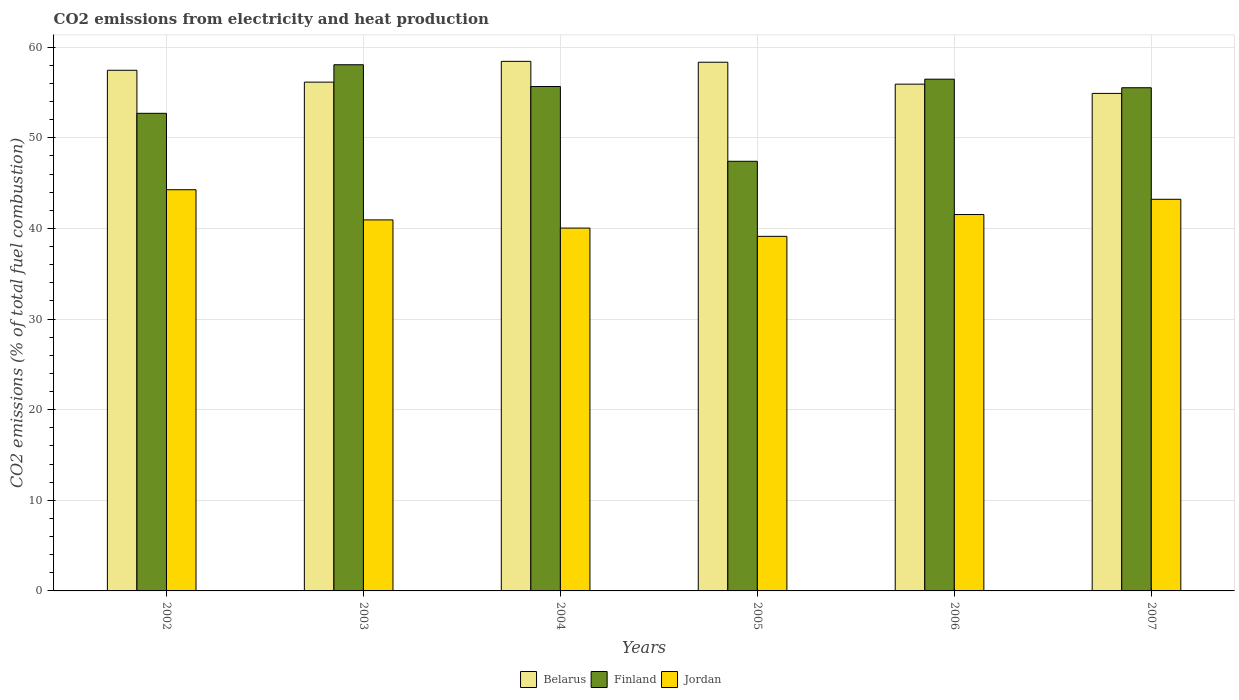How many bars are there on the 4th tick from the right?
Give a very brief answer. 3. What is the label of the 1st group of bars from the left?
Your answer should be compact. 2002. What is the amount of CO2 emitted in Belarus in 2006?
Your answer should be very brief. 55.92. Across all years, what is the maximum amount of CO2 emitted in Belarus?
Offer a very short reply. 58.43. Across all years, what is the minimum amount of CO2 emitted in Jordan?
Ensure brevity in your answer.  39.12. In which year was the amount of CO2 emitted in Belarus minimum?
Provide a succinct answer. 2007. What is the total amount of CO2 emitted in Belarus in the graph?
Keep it short and to the point. 341.17. What is the difference between the amount of CO2 emitted in Belarus in 2003 and that in 2005?
Offer a very short reply. -2.2. What is the difference between the amount of CO2 emitted in Belarus in 2005 and the amount of CO2 emitted in Finland in 2002?
Ensure brevity in your answer.  5.64. What is the average amount of CO2 emitted in Belarus per year?
Make the answer very short. 56.86. In the year 2007, what is the difference between the amount of CO2 emitted in Jordan and amount of CO2 emitted in Finland?
Ensure brevity in your answer.  -12.31. In how many years, is the amount of CO2 emitted in Finland greater than 38 %?
Your response must be concise. 6. What is the ratio of the amount of CO2 emitted in Jordan in 2003 to that in 2006?
Ensure brevity in your answer.  0.99. Is the difference between the amount of CO2 emitted in Jordan in 2002 and 2004 greater than the difference between the amount of CO2 emitted in Finland in 2002 and 2004?
Your response must be concise. Yes. What is the difference between the highest and the second highest amount of CO2 emitted in Jordan?
Keep it short and to the point. 1.05. What is the difference between the highest and the lowest amount of CO2 emitted in Jordan?
Keep it short and to the point. 5.14. In how many years, is the amount of CO2 emitted in Finland greater than the average amount of CO2 emitted in Finland taken over all years?
Offer a terse response. 4. Is the sum of the amount of CO2 emitted in Finland in 2003 and 2007 greater than the maximum amount of CO2 emitted in Jordan across all years?
Provide a short and direct response. Yes. What does the 3rd bar from the left in 2006 represents?
Provide a succinct answer. Jordan. What does the 3rd bar from the right in 2007 represents?
Make the answer very short. Belarus. Is it the case that in every year, the sum of the amount of CO2 emitted in Jordan and amount of CO2 emitted in Finland is greater than the amount of CO2 emitted in Belarus?
Provide a short and direct response. Yes. Are all the bars in the graph horizontal?
Ensure brevity in your answer.  No. How many years are there in the graph?
Your answer should be very brief. 6. What is the difference between two consecutive major ticks on the Y-axis?
Provide a succinct answer. 10. What is the title of the graph?
Your answer should be very brief. CO2 emissions from electricity and heat production. Does "Fragile and conflict affected situations" appear as one of the legend labels in the graph?
Provide a succinct answer. No. What is the label or title of the X-axis?
Provide a short and direct response. Years. What is the label or title of the Y-axis?
Your answer should be compact. CO2 emissions (% of total fuel combustion). What is the CO2 emissions (% of total fuel combustion) in Belarus in 2002?
Keep it short and to the point. 57.45. What is the CO2 emissions (% of total fuel combustion) in Finland in 2002?
Your answer should be compact. 52.7. What is the CO2 emissions (% of total fuel combustion) in Jordan in 2002?
Ensure brevity in your answer.  44.27. What is the CO2 emissions (% of total fuel combustion) of Belarus in 2003?
Your answer should be compact. 56.14. What is the CO2 emissions (% of total fuel combustion) in Finland in 2003?
Offer a terse response. 58.06. What is the CO2 emissions (% of total fuel combustion) of Jordan in 2003?
Ensure brevity in your answer.  40.94. What is the CO2 emissions (% of total fuel combustion) in Belarus in 2004?
Your response must be concise. 58.43. What is the CO2 emissions (% of total fuel combustion) in Finland in 2004?
Provide a succinct answer. 55.66. What is the CO2 emissions (% of total fuel combustion) of Jordan in 2004?
Offer a terse response. 40.04. What is the CO2 emissions (% of total fuel combustion) in Belarus in 2005?
Your answer should be compact. 58.34. What is the CO2 emissions (% of total fuel combustion) of Finland in 2005?
Ensure brevity in your answer.  47.41. What is the CO2 emissions (% of total fuel combustion) in Jordan in 2005?
Your response must be concise. 39.12. What is the CO2 emissions (% of total fuel combustion) in Belarus in 2006?
Provide a succinct answer. 55.92. What is the CO2 emissions (% of total fuel combustion) in Finland in 2006?
Keep it short and to the point. 56.47. What is the CO2 emissions (% of total fuel combustion) in Jordan in 2006?
Your answer should be compact. 41.53. What is the CO2 emissions (% of total fuel combustion) in Belarus in 2007?
Your answer should be compact. 54.9. What is the CO2 emissions (% of total fuel combustion) in Finland in 2007?
Provide a succinct answer. 55.52. What is the CO2 emissions (% of total fuel combustion) of Jordan in 2007?
Your answer should be very brief. 43.21. Across all years, what is the maximum CO2 emissions (% of total fuel combustion) of Belarus?
Provide a short and direct response. 58.43. Across all years, what is the maximum CO2 emissions (% of total fuel combustion) in Finland?
Your answer should be compact. 58.06. Across all years, what is the maximum CO2 emissions (% of total fuel combustion) in Jordan?
Make the answer very short. 44.27. Across all years, what is the minimum CO2 emissions (% of total fuel combustion) of Belarus?
Your answer should be very brief. 54.9. Across all years, what is the minimum CO2 emissions (% of total fuel combustion) of Finland?
Offer a very short reply. 47.41. Across all years, what is the minimum CO2 emissions (% of total fuel combustion) of Jordan?
Ensure brevity in your answer.  39.12. What is the total CO2 emissions (% of total fuel combustion) of Belarus in the graph?
Provide a succinct answer. 341.17. What is the total CO2 emissions (% of total fuel combustion) in Finland in the graph?
Give a very brief answer. 325.81. What is the total CO2 emissions (% of total fuel combustion) in Jordan in the graph?
Your answer should be very brief. 249.11. What is the difference between the CO2 emissions (% of total fuel combustion) of Belarus in 2002 and that in 2003?
Keep it short and to the point. 1.31. What is the difference between the CO2 emissions (% of total fuel combustion) in Finland in 2002 and that in 2003?
Keep it short and to the point. -5.36. What is the difference between the CO2 emissions (% of total fuel combustion) of Jordan in 2002 and that in 2003?
Give a very brief answer. 3.33. What is the difference between the CO2 emissions (% of total fuel combustion) of Belarus in 2002 and that in 2004?
Give a very brief answer. -0.98. What is the difference between the CO2 emissions (% of total fuel combustion) in Finland in 2002 and that in 2004?
Provide a short and direct response. -2.96. What is the difference between the CO2 emissions (% of total fuel combustion) in Jordan in 2002 and that in 2004?
Keep it short and to the point. 4.23. What is the difference between the CO2 emissions (% of total fuel combustion) in Belarus in 2002 and that in 2005?
Offer a very short reply. -0.89. What is the difference between the CO2 emissions (% of total fuel combustion) in Finland in 2002 and that in 2005?
Provide a short and direct response. 5.29. What is the difference between the CO2 emissions (% of total fuel combustion) of Jordan in 2002 and that in 2005?
Offer a very short reply. 5.14. What is the difference between the CO2 emissions (% of total fuel combustion) in Belarus in 2002 and that in 2006?
Offer a very short reply. 1.53. What is the difference between the CO2 emissions (% of total fuel combustion) of Finland in 2002 and that in 2006?
Your answer should be compact. -3.77. What is the difference between the CO2 emissions (% of total fuel combustion) of Jordan in 2002 and that in 2006?
Make the answer very short. 2.74. What is the difference between the CO2 emissions (% of total fuel combustion) of Belarus in 2002 and that in 2007?
Your answer should be very brief. 2.55. What is the difference between the CO2 emissions (% of total fuel combustion) in Finland in 2002 and that in 2007?
Your answer should be compact. -2.82. What is the difference between the CO2 emissions (% of total fuel combustion) in Jordan in 2002 and that in 2007?
Keep it short and to the point. 1.05. What is the difference between the CO2 emissions (% of total fuel combustion) in Belarus in 2003 and that in 2004?
Make the answer very short. -2.29. What is the difference between the CO2 emissions (% of total fuel combustion) in Finland in 2003 and that in 2004?
Offer a terse response. 2.4. What is the difference between the CO2 emissions (% of total fuel combustion) of Jordan in 2003 and that in 2004?
Give a very brief answer. 0.9. What is the difference between the CO2 emissions (% of total fuel combustion) in Belarus in 2003 and that in 2005?
Keep it short and to the point. -2.2. What is the difference between the CO2 emissions (% of total fuel combustion) in Finland in 2003 and that in 2005?
Your answer should be compact. 10.65. What is the difference between the CO2 emissions (% of total fuel combustion) of Jordan in 2003 and that in 2005?
Provide a succinct answer. 1.82. What is the difference between the CO2 emissions (% of total fuel combustion) in Belarus in 2003 and that in 2006?
Provide a succinct answer. 0.22. What is the difference between the CO2 emissions (% of total fuel combustion) of Finland in 2003 and that in 2006?
Your response must be concise. 1.59. What is the difference between the CO2 emissions (% of total fuel combustion) of Jordan in 2003 and that in 2006?
Your answer should be very brief. -0.59. What is the difference between the CO2 emissions (% of total fuel combustion) in Belarus in 2003 and that in 2007?
Keep it short and to the point. 1.24. What is the difference between the CO2 emissions (% of total fuel combustion) in Finland in 2003 and that in 2007?
Your response must be concise. 2.54. What is the difference between the CO2 emissions (% of total fuel combustion) of Jordan in 2003 and that in 2007?
Offer a terse response. -2.27. What is the difference between the CO2 emissions (% of total fuel combustion) in Belarus in 2004 and that in 2005?
Make the answer very short. 0.1. What is the difference between the CO2 emissions (% of total fuel combustion) in Finland in 2004 and that in 2005?
Your response must be concise. 8.25. What is the difference between the CO2 emissions (% of total fuel combustion) in Jordan in 2004 and that in 2005?
Give a very brief answer. 0.91. What is the difference between the CO2 emissions (% of total fuel combustion) of Belarus in 2004 and that in 2006?
Make the answer very short. 2.52. What is the difference between the CO2 emissions (% of total fuel combustion) of Finland in 2004 and that in 2006?
Provide a succinct answer. -0.81. What is the difference between the CO2 emissions (% of total fuel combustion) in Jordan in 2004 and that in 2006?
Your response must be concise. -1.5. What is the difference between the CO2 emissions (% of total fuel combustion) of Belarus in 2004 and that in 2007?
Offer a very short reply. 3.54. What is the difference between the CO2 emissions (% of total fuel combustion) in Finland in 2004 and that in 2007?
Your answer should be compact. 0.14. What is the difference between the CO2 emissions (% of total fuel combustion) of Jordan in 2004 and that in 2007?
Give a very brief answer. -3.18. What is the difference between the CO2 emissions (% of total fuel combustion) of Belarus in 2005 and that in 2006?
Your answer should be very brief. 2.42. What is the difference between the CO2 emissions (% of total fuel combustion) of Finland in 2005 and that in 2006?
Make the answer very short. -9.06. What is the difference between the CO2 emissions (% of total fuel combustion) in Jordan in 2005 and that in 2006?
Give a very brief answer. -2.41. What is the difference between the CO2 emissions (% of total fuel combustion) in Belarus in 2005 and that in 2007?
Your answer should be very brief. 3.44. What is the difference between the CO2 emissions (% of total fuel combustion) in Finland in 2005 and that in 2007?
Provide a succinct answer. -8.12. What is the difference between the CO2 emissions (% of total fuel combustion) of Jordan in 2005 and that in 2007?
Offer a very short reply. -4.09. What is the difference between the CO2 emissions (% of total fuel combustion) of Belarus in 2006 and that in 2007?
Your answer should be very brief. 1.02. What is the difference between the CO2 emissions (% of total fuel combustion) of Finland in 2006 and that in 2007?
Provide a short and direct response. 0.95. What is the difference between the CO2 emissions (% of total fuel combustion) of Jordan in 2006 and that in 2007?
Make the answer very short. -1.68. What is the difference between the CO2 emissions (% of total fuel combustion) in Belarus in 2002 and the CO2 emissions (% of total fuel combustion) in Finland in 2003?
Keep it short and to the point. -0.61. What is the difference between the CO2 emissions (% of total fuel combustion) of Belarus in 2002 and the CO2 emissions (% of total fuel combustion) of Jordan in 2003?
Your response must be concise. 16.51. What is the difference between the CO2 emissions (% of total fuel combustion) in Finland in 2002 and the CO2 emissions (% of total fuel combustion) in Jordan in 2003?
Make the answer very short. 11.76. What is the difference between the CO2 emissions (% of total fuel combustion) of Belarus in 2002 and the CO2 emissions (% of total fuel combustion) of Finland in 2004?
Offer a very short reply. 1.79. What is the difference between the CO2 emissions (% of total fuel combustion) of Belarus in 2002 and the CO2 emissions (% of total fuel combustion) of Jordan in 2004?
Ensure brevity in your answer.  17.41. What is the difference between the CO2 emissions (% of total fuel combustion) of Finland in 2002 and the CO2 emissions (% of total fuel combustion) of Jordan in 2004?
Offer a terse response. 12.66. What is the difference between the CO2 emissions (% of total fuel combustion) in Belarus in 2002 and the CO2 emissions (% of total fuel combustion) in Finland in 2005?
Offer a terse response. 10.04. What is the difference between the CO2 emissions (% of total fuel combustion) in Belarus in 2002 and the CO2 emissions (% of total fuel combustion) in Jordan in 2005?
Your response must be concise. 18.32. What is the difference between the CO2 emissions (% of total fuel combustion) of Finland in 2002 and the CO2 emissions (% of total fuel combustion) of Jordan in 2005?
Your answer should be compact. 13.58. What is the difference between the CO2 emissions (% of total fuel combustion) in Belarus in 2002 and the CO2 emissions (% of total fuel combustion) in Finland in 2006?
Offer a terse response. 0.98. What is the difference between the CO2 emissions (% of total fuel combustion) of Belarus in 2002 and the CO2 emissions (% of total fuel combustion) of Jordan in 2006?
Your answer should be compact. 15.92. What is the difference between the CO2 emissions (% of total fuel combustion) in Finland in 2002 and the CO2 emissions (% of total fuel combustion) in Jordan in 2006?
Offer a very short reply. 11.17. What is the difference between the CO2 emissions (% of total fuel combustion) in Belarus in 2002 and the CO2 emissions (% of total fuel combustion) in Finland in 2007?
Provide a succinct answer. 1.93. What is the difference between the CO2 emissions (% of total fuel combustion) in Belarus in 2002 and the CO2 emissions (% of total fuel combustion) in Jordan in 2007?
Offer a terse response. 14.23. What is the difference between the CO2 emissions (% of total fuel combustion) of Finland in 2002 and the CO2 emissions (% of total fuel combustion) of Jordan in 2007?
Keep it short and to the point. 9.48. What is the difference between the CO2 emissions (% of total fuel combustion) in Belarus in 2003 and the CO2 emissions (% of total fuel combustion) in Finland in 2004?
Your response must be concise. 0.48. What is the difference between the CO2 emissions (% of total fuel combustion) of Belarus in 2003 and the CO2 emissions (% of total fuel combustion) of Jordan in 2004?
Your answer should be very brief. 16.1. What is the difference between the CO2 emissions (% of total fuel combustion) of Finland in 2003 and the CO2 emissions (% of total fuel combustion) of Jordan in 2004?
Keep it short and to the point. 18.02. What is the difference between the CO2 emissions (% of total fuel combustion) of Belarus in 2003 and the CO2 emissions (% of total fuel combustion) of Finland in 2005?
Offer a terse response. 8.73. What is the difference between the CO2 emissions (% of total fuel combustion) in Belarus in 2003 and the CO2 emissions (% of total fuel combustion) in Jordan in 2005?
Make the answer very short. 17.02. What is the difference between the CO2 emissions (% of total fuel combustion) in Finland in 2003 and the CO2 emissions (% of total fuel combustion) in Jordan in 2005?
Your answer should be compact. 18.94. What is the difference between the CO2 emissions (% of total fuel combustion) of Belarus in 2003 and the CO2 emissions (% of total fuel combustion) of Finland in 2006?
Ensure brevity in your answer.  -0.33. What is the difference between the CO2 emissions (% of total fuel combustion) of Belarus in 2003 and the CO2 emissions (% of total fuel combustion) of Jordan in 2006?
Offer a terse response. 14.61. What is the difference between the CO2 emissions (% of total fuel combustion) of Finland in 2003 and the CO2 emissions (% of total fuel combustion) of Jordan in 2006?
Provide a succinct answer. 16.53. What is the difference between the CO2 emissions (% of total fuel combustion) of Belarus in 2003 and the CO2 emissions (% of total fuel combustion) of Finland in 2007?
Your answer should be very brief. 0.62. What is the difference between the CO2 emissions (% of total fuel combustion) in Belarus in 2003 and the CO2 emissions (% of total fuel combustion) in Jordan in 2007?
Provide a short and direct response. 12.93. What is the difference between the CO2 emissions (% of total fuel combustion) in Finland in 2003 and the CO2 emissions (% of total fuel combustion) in Jordan in 2007?
Your response must be concise. 14.85. What is the difference between the CO2 emissions (% of total fuel combustion) of Belarus in 2004 and the CO2 emissions (% of total fuel combustion) of Finland in 2005?
Your answer should be very brief. 11.03. What is the difference between the CO2 emissions (% of total fuel combustion) of Belarus in 2004 and the CO2 emissions (% of total fuel combustion) of Jordan in 2005?
Provide a short and direct response. 19.31. What is the difference between the CO2 emissions (% of total fuel combustion) of Finland in 2004 and the CO2 emissions (% of total fuel combustion) of Jordan in 2005?
Offer a terse response. 16.53. What is the difference between the CO2 emissions (% of total fuel combustion) of Belarus in 2004 and the CO2 emissions (% of total fuel combustion) of Finland in 2006?
Ensure brevity in your answer.  1.97. What is the difference between the CO2 emissions (% of total fuel combustion) in Belarus in 2004 and the CO2 emissions (% of total fuel combustion) in Jordan in 2006?
Your answer should be compact. 16.9. What is the difference between the CO2 emissions (% of total fuel combustion) of Finland in 2004 and the CO2 emissions (% of total fuel combustion) of Jordan in 2006?
Provide a short and direct response. 14.13. What is the difference between the CO2 emissions (% of total fuel combustion) of Belarus in 2004 and the CO2 emissions (% of total fuel combustion) of Finland in 2007?
Your response must be concise. 2.91. What is the difference between the CO2 emissions (% of total fuel combustion) of Belarus in 2004 and the CO2 emissions (% of total fuel combustion) of Jordan in 2007?
Give a very brief answer. 15.22. What is the difference between the CO2 emissions (% of total fuel combustion) of Finland in 2004 and the CO2 emissions (% of total fuel combustion) of Jordan in 2007?
Give a very brief answer. 12.44. What is the difference between the CO2 emissions (% of total fuel combustion) in Belarus in 2005 and the CO2 emissions (% of total fuel combustion) in Finland in 2006?
Provide a short and direct response. 1.87. What is the difference between the CO2 emissions (% of total fuel combustion) of Belarus in 2005 and the CO2 emissions (% of total fuel combustion) of Jordan in 2006?
Offer a terse response. 16.81. What is the difference between the CO2 emissions (% of total fuel combustion) in Finland in 2005 and the CO2 emissions (% of total fuel combustion) in Jordan in 2006?
Make the answer very short. 5.87. What is the difference between the CO2 emissions (% of total fuel combustion) of Belarus in 2005 and the CO2 emissions (% of total fuel combustion) of Finland in 2007?
Ensure brevity in your answer.  2.82. What is the difference between the CO2 emissions (% of total fuel combustion) in Belarus in 2005 and the CO2 emissions (% of total fuel combustion) in Jordan in 2007?
Offer a very short reply. 15.12. What is the difference between the CO2 emissions (% of total fuel combustion) in Finland in 2005 and the CO2 emissions (% of total fuel combustion) in Jordan in 2007?
Offer a terse response. 4.19. What is the difference between the CO2 emissions (% of total fuel combustion) of Belarus in 2006 and the CO2 emissions (% of total fuel combustion) of Finland in 2007?
Your answer should be very brief. 0.4. What is the difference between the CO2 emissions (% of total fuel combustion) of Belarus in 2006 and the CO2 emissions (% of total fuel combustion) of Jordan in 2007?
Offer a terse response. 12.7. What is the difference between the CO2 emissions (% of total fuel combustion) in Finland in 2006 and the CO2 emissions (% of total fuel combustion) in Jordan in 2007?
Your response must be concise. 13.25. What is the average CO2 emissions (% of total fuel combustion) of Belarus per year?
Keep it short and to the point. 56.86. What is the average CO2 emissions (% of total fuel combustion) in Finland per year?
Offer a terse response. 54.3. What is the average CO2 emissions (% of total fuel combustion) of Jordan per year?
Your response must be concise. 41.52. In the year 2002, what is the difference between the CO2 emissions (% of total fuel combustion) of Belarus and CO2 emissions (% of total fuel combustion) of Finland?
Offer a very short reply. 4.75. In the year 2002, what is the difference between the CO2 emissions (% of total fuel combustion) of Belarus and CO2 emissions (% of total fuel combustion) of Jordan?
Provide a succinct answer. 13.18. In the year 2002, what is the difference between the CO2 emissions (% of total fuel combustion) in Finland and CO2 emissions (% of total fuel combustion) in Jordan?
Your answer should be compact. 8.43. In the year 2003, what is the difference between the CO2 emissions (% of total fuel combustion) in Belarus and CO2 emissions (% of total fuel combustion) in Finland?
Give a very brief answer. -1.92. In the year 2003, what is the difference between the CO2 emissions (% of total fuel combustion) in Belarus and CO2 emissions (% of total fuel combustion) in Jordan?
Your answer should be compact. 15.2. In the year 2003, what is the difference between the CO2 emissions (% of total fuel combustion) in Finland and CO2 emissions (% of total fuel combustion) in Jordan?
Provide a short and direct response. 17.12. In the year 2004, what is the difference between the CO2 emissions (% of total fuel combustion) of Belarus and CO2 emissions (% of total fuel combustion) of Finland?
Your answer should be very brief. 2.78. In the year 2004, what is the difference between the CO2 emissions (% of total fuel combustion) in Belarus and CO2 emissions (% of total fuel combustion) in Jordan?
Give a very brief answer. 18.4. In the year 2004, what is the difference between the CO2 emissions (% of total fuel combustion) in Finland and CO2 emissions (% of total fuel combustion) in Jordan?
Your answer should be very brief. 15.62. In the year 2005, what is the difference between the CO2 emissions (% of total fuel combustion) of Belarus and CO2 emissions (% of total fuel combustion) of Finland?
Keep it short and to the point. 10.93. In the year 2005, what is the difference between the CO2 emissions (% of total fuel combustion) of Belarus and CO2 emissions (% of total fuel combustion) of Jordan?
Provide a succinct answer. 19.21. In the year 2005, what is the difference between the CO2 emissions (% of total fuel combustion) in Finland and CO2 emissions (% of total fuel combustion) in Jordan?
Offer a very short reply. 8.28. In the year 2006, what is the difference between the CO2 emissions (% of total fuel combustion) in Belarus and CO2 emissions (% of total fuel combustion) in Finland?
Your answer should be compact. -0.55. In the year 2006, what is the difference between the CO2 emissions (% of total fuel combustion) in Belarus and CO2 emissions (% of total fuel combustion) in Jordan?
Your response must be concise. 14.39. In the year 2006, what is the difference between the CO2 emissions (% of total fuel combustion) of Finland and CO2 emissions (% of total fuel combustion) of Jordan?
Your answer should be compact. 14.94. In the year 2007, what is the difference between the CO2 emissions (% of total fuel combustion) in Belarus and CO2 emissions (% of total fuel combustion) in Finland?
Your answer should be very brief. -0.62. In the year 2007, what is the difference between the CO2 emissions (% of total fuel combustion) in Belarus and CO2 emissions (% of total fuel combustion) in Jordan?
Your response must be concise. 11.68. In the year 2007, what is the difference between the CO2 emissions (% of total fuel combustion) of Finland and CO2 emissions (% of total fuel combustion) of Jordan?
Your answer should be very brief. 12.31. What is the ratio of the CO2 emissions (% of total fuel combustion) of Belarus in 2002 to that in 2003?
Ensure brevity in your answer.  1.02. What is the ratio of the CO2 emissions (% of total fuel combustion) in Finland in 2002 to that in 2003?
Give a very brief answer. 0.91. What is the ratio of the CO2 emissions (% of total fuel combustion) of Jordan in 2002 to that in 2003?
Your answer should be compact. 1.08. What is the ratio of the CO2 emissions (% of total fuel combustion) in Belarus in 2002 to that in 2004?
Ensure brevity in your answer.  0.98. What is the ratio of the CO2 emissions (% of total fuel combustion) of Finland in 2002 to that in 2004?
Make the answer very short. 0.95. What is the ratio of the CO2 emissions (% of total fuel combustion) in Jordan in 2002 to that in 2004?
Offer a very short reply. 1.11. What is the ratio of the CO2 emissions (% of total fuel combustion) in Belarus in 2002 to that in 2005?
Make the answer very short. 0.98. What is the ratio of the CO2 emissions (% of total fuel combustion) of Finland in 2002 to that in 2005?
Give a very brief answer. 1.11. What is the ratio of the CO2 emissions (% of total fuel combustion) of Jordan in 2002 to that in 2005?
Give a very brief answer. 1.13. What is the ratio of the CO2 emissions (% of total fuel combustion) of Belarus in 2002 to that in 2006?
Make the answer very short. 1.03. What is the ratio of the CO2 emissions (% of total fuel combustion) of Jordan in 2002 to that in 2006?
Your response must be concise. 1.07. What is the ratio of the CO2 emissions (% of total fuel combustion) in Belarus in 2002 to that in 2007?
Ensure brevity in your answer.  1.05. What is the ratio of the CO2 emissions (% of total fuel combustion) of Finland in 2002 to that in 2007?
Keep it short and to the point. 0.95. What is the ratio of the CO2 emissions (% of total fuel combustion) in Jordan in 2002 to that in 2007?
Provide a short and direct response. 1.02. What is the ratio of the CO2 emissions (% of total fuel combustion) in Belarus in 2003 to that in 2004?
Keep it short and to the point. 0.96. What is the ratio of the CO2 emissions (% of total fuel combustion) of Finland in 2003 to that in 2004?
Keep it short and to the point. 1.04. What is the ratio of the CO2 emissions (% of total fuel combustion) in Jordan in 2003 to that in 2004?
Make the answer very short. 1.02. What is the ratio of the CO2 emissions (% of total fuel combustion) of Belarus in 2003 to that in 2005?
Provide a succinct answer. 0.96. What is the ratio of the CO2 emissions (% of total fuel combustion) in Finland in 2003 to that in 2005?
Offer a terse response. 1.22. What is the ratio of the CO2 emissions (% of total fuel combustion) of Jordan in 2003 to that in 2005?
Your answer should be compact. 1.05. What is the ratio of the CO2 emissions (% of total fuel combustion) in Belarus in 2003 to that in 2006?
Make the answer very short. 1. What is the ratio of the CO2 emissions (% of total fuel combustion) in Finland in 2003 to that in 2006?
Provide a succinct answer. 1.03. What is the ratio of the CO2 emissions (% of total fuel combustion) in Jordan in 2003 to that in 2006?
Offer a very short reply. 0.99. What is the ratio of the CO2 emissions (% of total fuel combustion) of Belarus in 2003 to that in 2007?
Your response must be concise. 1.02. What is the ratio of the CO2 emissions (% of total fuel combustion) in Finland in 2003 to that in 2007?
Provide a succinct answer. 1.05. What is the ratio of the CO2 emissions (% of total fuel combustion) in Belarus in 2004 to that in 2005?
Your response must be concise. 1. What is the ratio of the CO2 emissions (% of total fuel combustion) in Finland in 2004 to that in 2005?
Offer a very short reply. 1.17. What is the ratio of the CO2 emissions (% of total fuel combustion) of Jordan in 2004 to that in 2005?
Your answer should be very brief. 1.02. What is the ratio of the CO2 emissions (% of total fuel combustion) of Belarus in 2004 to that in 2006?
Provide a short and direct response. 1.04. What is the ratio of the CO2 emissions (% of total fuel combustion) of Finland in 2004 to that in 2006?
Give a very brief answer. 0.99. What is the ratio of the CO2 emissions (% of total fuel combustion) in Belarus in 2004 to that in 2007?
Your answer should be compact. 1.06. What is the ratio of the CO2 emissions (% of total fuel combustion) in Jordan in 2004 to that in 2007?
Ensure brevity in your answer.  0.93. What is the ratio of the CO2 emissions (% of total fuel combustion) of Belarus in 2005 to that in 2006?
Your response must be concise. 1.04. What is the ratio of the CO2 emissions (% of total fuel combustion) in Finland in 2005 to that in 2006?
Your answer should be compact. 0.84. What is the ratio of the CO2 emissions (% of total fuel combustion) of Jordan in 2005 to that in 2006?
Your answer should be very brief. 0.94. What is the ratio of the CO2 emissions (% of total fuel combustion) of Belarus in 2005 to that in 2007?
Keep it short and to the point. 1.06. What is the ratio of the CO2 emissions (% of total fuel combustion) in Finland in 2005 to that in 2007?
Your response must be concise. 0.85. What is the ratio of the CO2 emissions (% of total fuel combustion) in Jordan in 2005 to that in 2007?
Make the answer very short. 0.91. What is the ratio of the CO2 emissions (% of total fuel combustion) of Belarus in 2006 to that in 2007?
Provide a short and direct response. 1.02. What is the ratio of the CO2 emissions (% of total fuel combustion) in Finland in 2006 to that in 2007?
Your response must be concise. 1.02. What is the ratio of the CO2 emissions (% of total fuel combustion) in Jordan in 2006 to that in 2007?
Provide a succinct answer. 0.96. What is the difference between the highest and the second highest CO2 emissions (% of total fuel combustion) in Belarus?
Ensure brevity in your answer.  0.1. What is the difference between the highest and the second highest CO2 emissions (% of total fuel combustion) in Finland?
Provide a succinct answer. 1.59. What is the difference between the highest and the second highest CO2 emissions (% of total fuel combustion) in Jordan?
Provide a short and direct response. 1.05. What is the difference between the highest and the lowest CO2 emissions (% of total fuel combustion) in Belarus?
Provide a succinct answer. 3.54. What is the difference between the highest and the lowest CO2 emissions (% of total fuel combustion) in Finland?
Your answer should be compact. 10.65. What is the difference between the highest and the lowest CO2 emissions (% of total fuel combustion) in Jordan?
Your answer should be very brief. 5.14. 